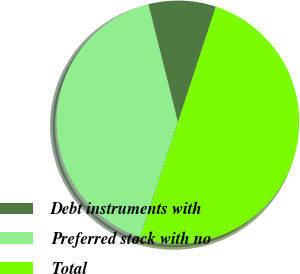Convert chart. <chart><loc_0><loc_0><loc_500><loc_500><pie_chart><fcel>Debt instruments with<fcel>Preferred stock with no<fcel>Total<nl><fcel>8.97%<fcel>41.03%<fcel>50.0%<nl></chart> 